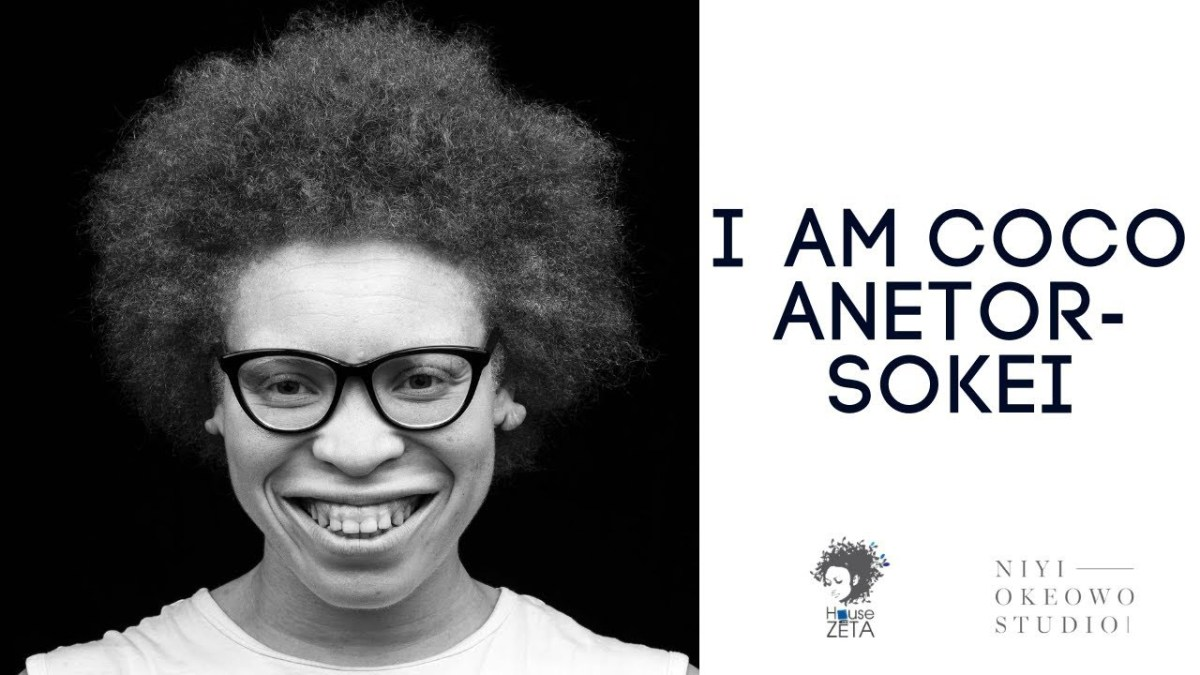What could the relationship be between the person in the image and the name mentioned in the text, considering the emphatic nature of the statement and the logo design? The image prominently features a person identified by the text as 'Coco Anetor-Sokei.' The emphatic statement 'I AM COCO ANETOR-SOKEI' coulpled with the cheerful and confident expression presents a strong personal identity. The logo at the bottom right, attributed to 'Niyi Okeowo Studio' and marked with a stylized profile that mimics the person's distinctive hairstyle, suggests a deep, personal brand connection. This logo likely represents the person's artistic or professional brand, emphasizing their unique style and perhaps their collaboration or representation by Niyi Okeowo Studio. 